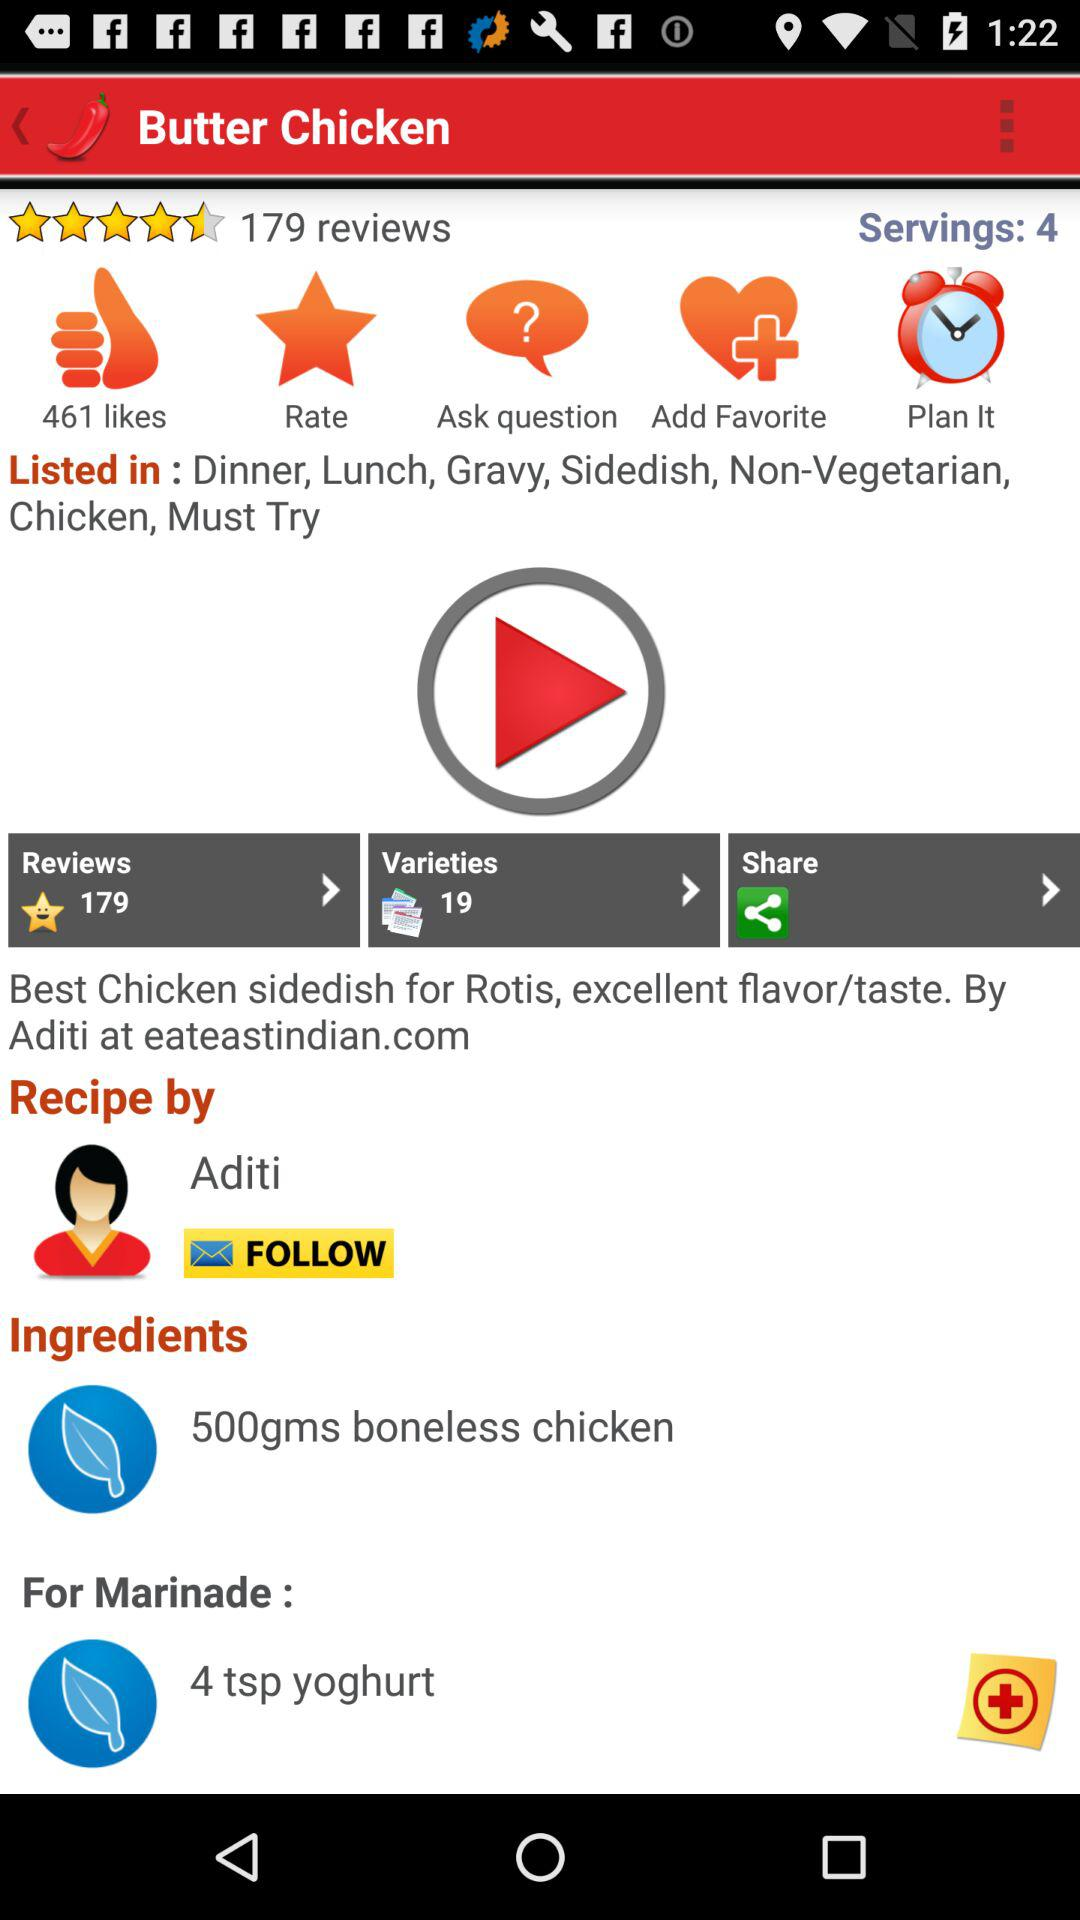How many more likes does this recipe have than reviews?
Answer the question using a single word or phrase. 282 